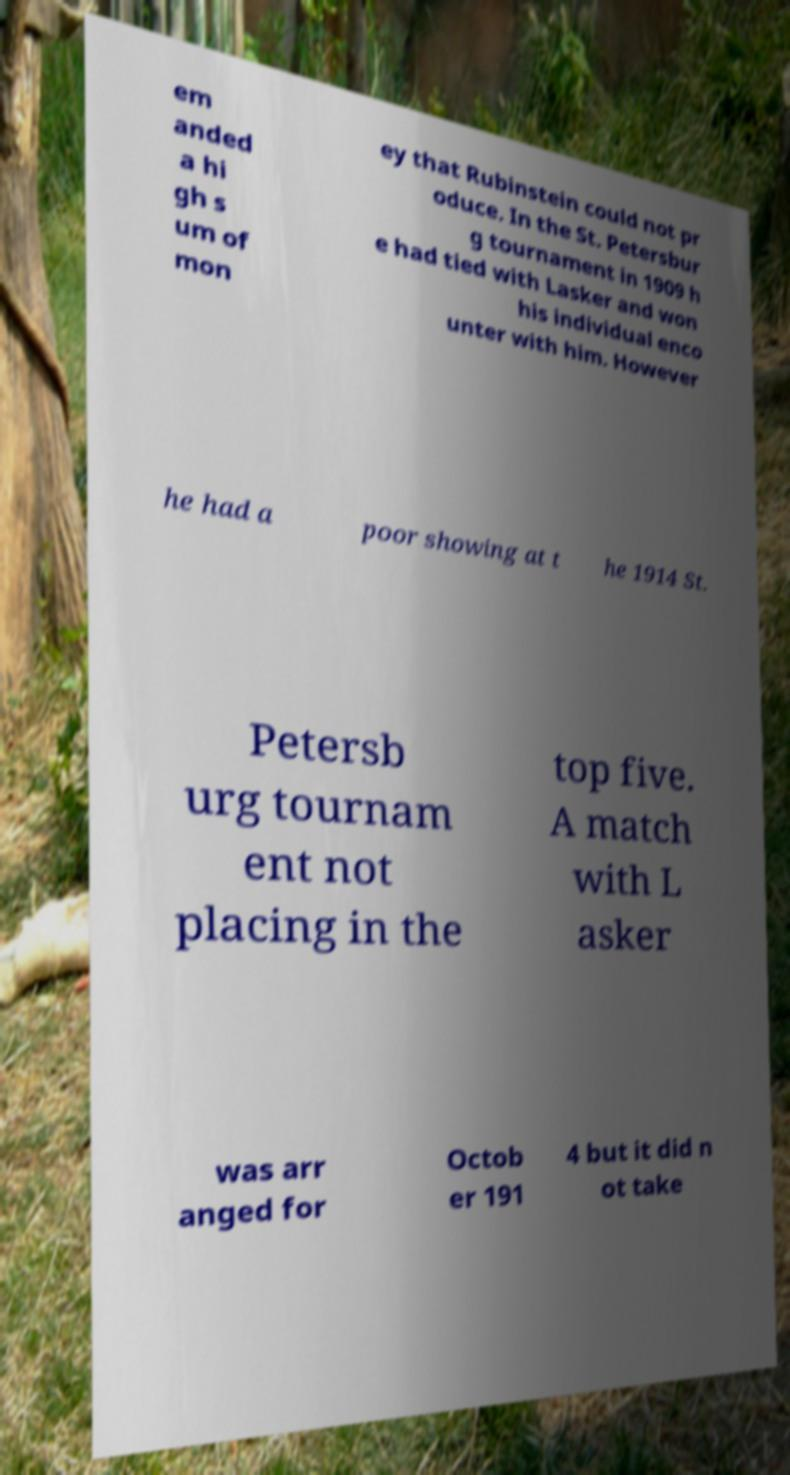Please identify and transcribe the text found in this image. em anded a hi gh s um of mon ey that Rubinstein could not pr oduce. In the St. Petersbur g tournament in 1909 h e had tied with Lasker and won his individual enco unter with him. However he had a poor showing at t he 1914 St. Petersb urg tournam ent not placing in the top five. A match with L asker was arr anged for Octob er 191 4 but it did n ot take 